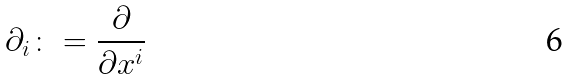Convert formula to latex. <formula><loc_0><loc_0><loc_500><loc_500>\partial _ { i } \colon = \frac { \partial } { \partial x ^ { i } }</formula> 